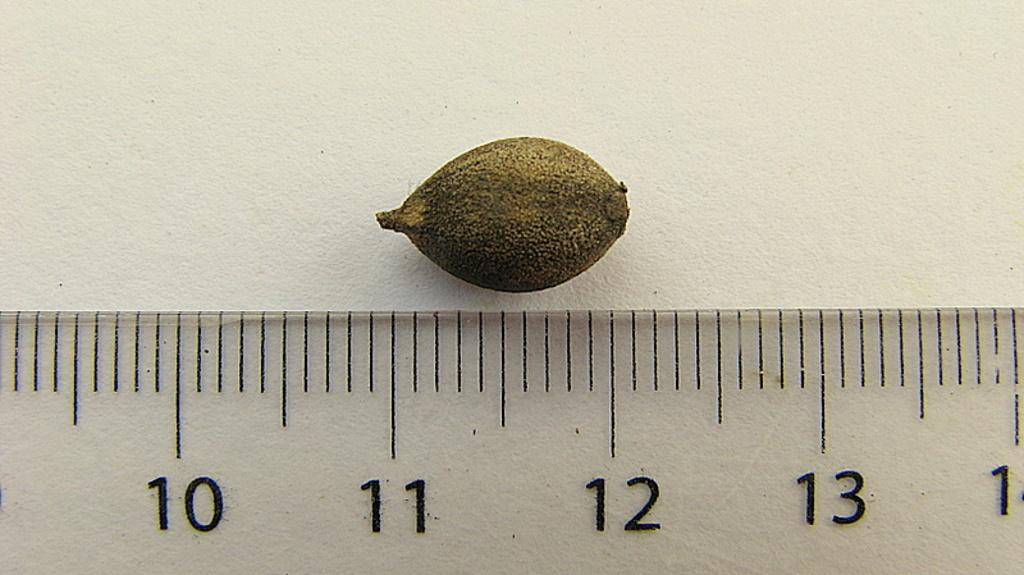<image>
Give a short and clear explanation of the subsequent image. Ruler being used to measure a seed which is above the 11 and 12 inch markers. 